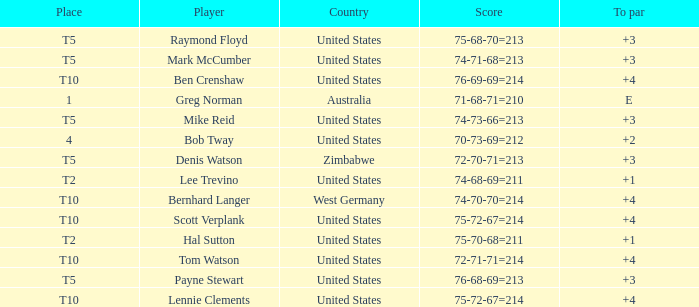What is player raymond floyd's country? United States. 